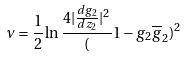Convert formula to latex. <formula><loc_0><loc_0><loc_500><loc_500>\nu = \frac { 1 } { 2 } \ln \frac { 4 | \frac { d g _ { 2 } } { d z _ { 2 } } | ^ { 2 } } ( 1 - g _ { 2 } \overline { g } _ { 2 } ) ^ { 2 }</formula> 